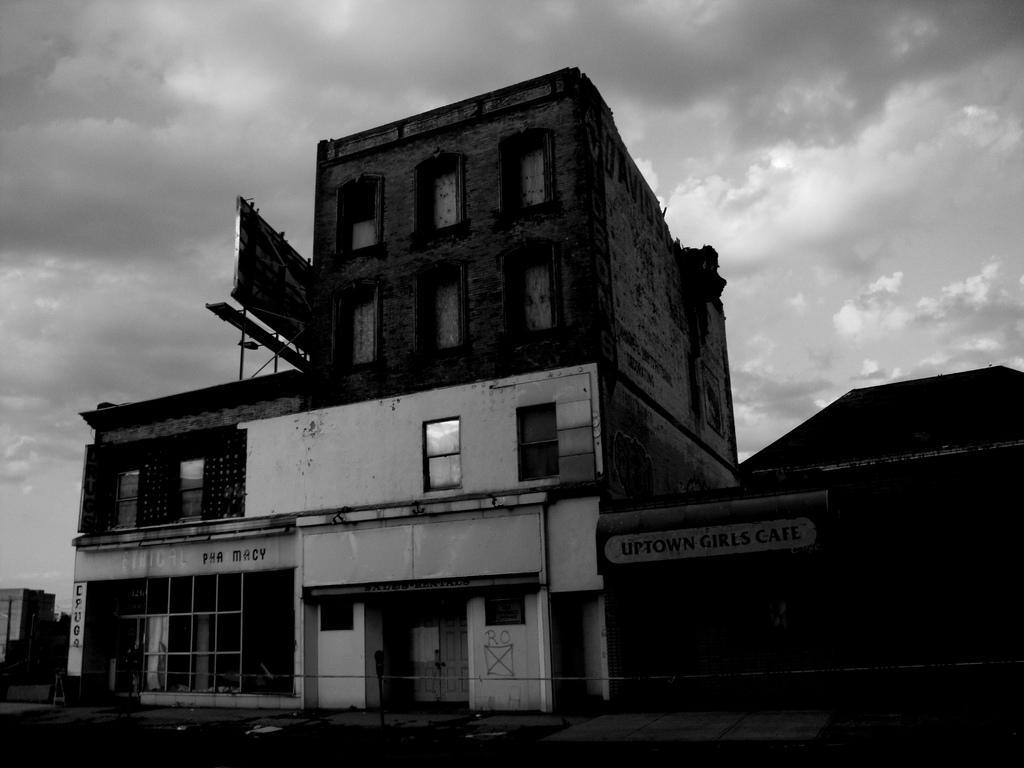Can you describe this image briefly? In this picture I can see buildings and boards with some text and I can see cloudy sky. 